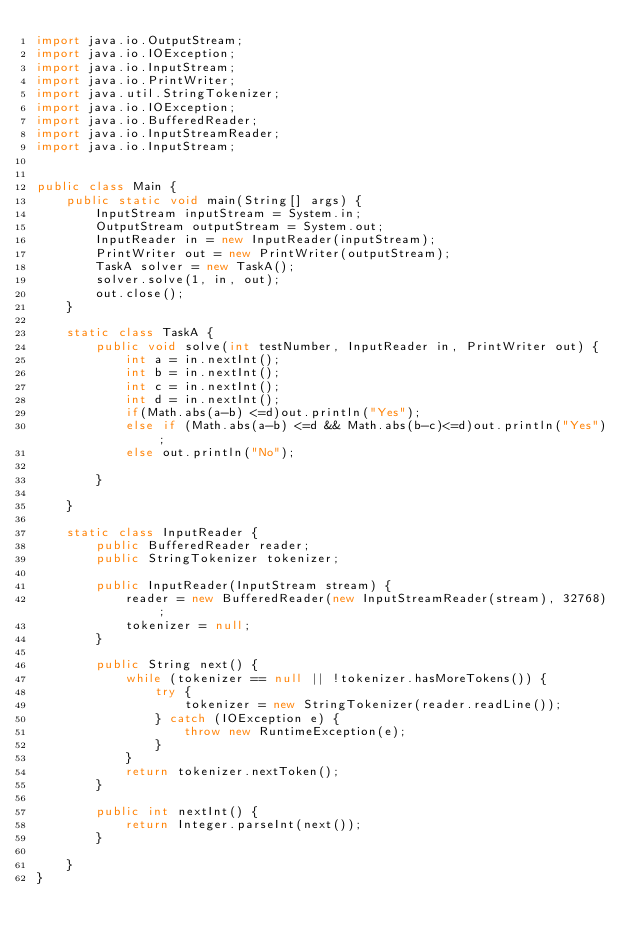Convert code to text. <code><loc_0><loc_0><loc_500><loc_500><_Java_>import java.io.OutputStream;
import java.io.IOException;
import java.io.InputStream;
import java.io.PrintWriter;
import java.util.StringTokenizer;
import java.io.IOException;
import java.io.BufferedReader;
import java.io.InputStreamReader;
import java.io.InputStream;


public class Main {
    public static void main(String[] args) {
        InputStream inputStream = System.in;
        OutputStream outputStream = System.out;
        InputReader in = new InputReader(inputStream);
        PrintWriter out = new PrintWriter(outputStream);
        TaskA solver = new TaskA();
        solver.solve(1, in, out);
        out.close();
    }

    static class TaskA {
        public void solve(int testNumber, InputReader in, PrintWriter out) {
            int a = in.nextInt();
            int b = in.nextInt();
            int c = in.nextInt();
            int d = in.nextInt();
            if(Math.abs(a-b) <=d)out.println("Yes");
            else if (Math.abs(a-b) <=d && Math.abs(b-c)<=d)out.println("Yes");
            else out.println("No");

        }

    }

    static class InputReader {
        public BufferedReader reader;
        public StringTokenizer tokenizer;

        public InputReader(InputStream stream) {
            reader = new BufferedReader(new InputStreamReader(stream), 32768);
            tokenizer = null;
        }

        public String next() {
            while (tokenizer == null || !tokenizer.hasMoreTokens()) {
                try {
                    tokenizer = new StringTokenizer(reader.readLine());
                } catch (IOException e) {
                    throw new RuntimeException(e);
                }
            }
            return tokenizer.nextToken();
        }

        public int nextInt() {
            return Integer.parseInt(next());
        }

    }
}
</code> 